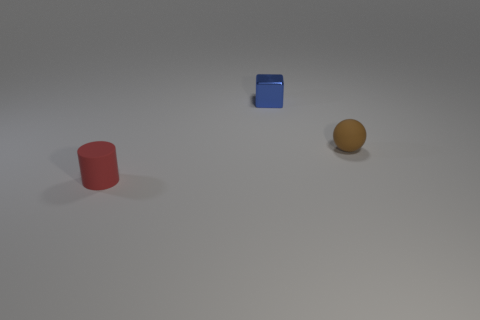There is a matte thing behind the matte cylinder; is its size the same as the tiny rubber cylinder?
Offer a terse response. Yes. How many things are small objects right of the small cylinder or objects left of the ball?
Ensure brevity in your answer.  3. Do the tiny rubber object left of the tiny metallic object and the shiny cube have the same color?
Ensure brevity in your answer.  No. What number of metal things are green objects or red things?
Keep it short and to the point. 0. What is the shape of the red matte object?
Your answer should be very brief. Cylinder. Is there anything else that is the same material as the blue thing?
Give a very brief answer. No. Are the tiny red thing and the brown ball made of the same material?
Provide a succinct answer. Yes. Is there a small red cylinder that is to the left of the tiny matte thing that is right of the small matte cylinder that is in front of the small brown ball?
Ensure brevity in your answer.  Yes. How many other objects are the same shape as the tiny blue object?
Give a very brief answer. 0. What is the shape of the small thing that is both in front of the tiny blue shiny block and to the left of the sphere?
Offer a very short reply. Cylinder. 